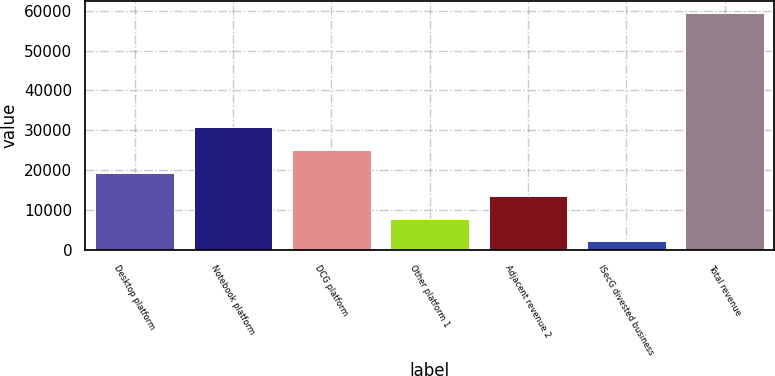<chart> <loc_0><loc_0><loc_500><loc_500><bar_chart><fcel>Desktop platform<fcel>Notebook platform<fcel>DCG platform<fcel>Other platform 1<fcel>Adjacent revenue 2<fcel>ISecG divested business<fcel>Total revenue<nl><fcel>19328.8<fcel>30774<fcel>25051.4<fcel>7883.6<fcel>13606.2<fcel>2161<fcel>59387<nl></chart> 